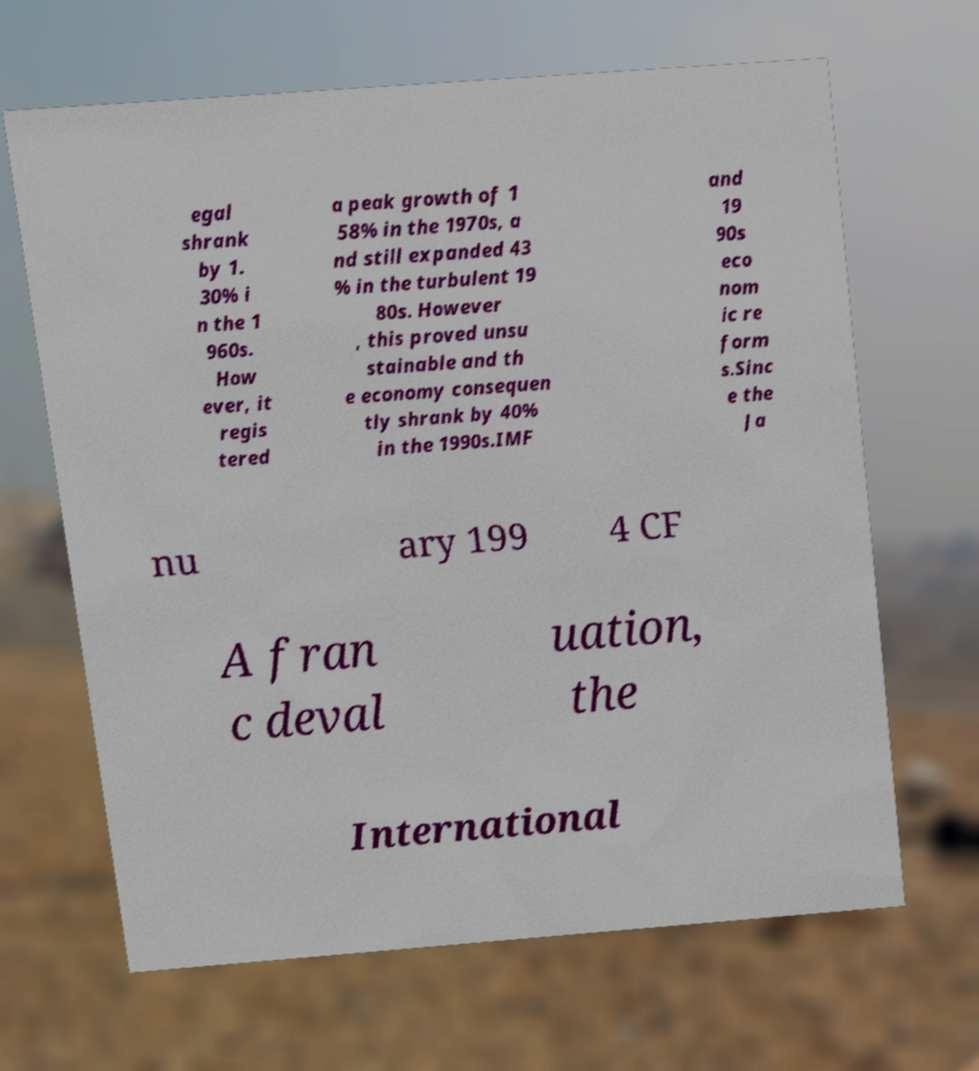For documentation purposes, I need the text within this image transcribed. Could you provide that? egal shrank by 1. 30% i n the 1 960s. How ever, it regis tered a peak growth of 1 58% in the 1970s, a nd still expanded 43 % in the turbulent 19 80s. However , this proved unsu stainable and th e economy consequen tly shrank by 40% in the 1990s.IMF and 19 90s eco nom ic re form s.Sinc e the Ja nu ary 199 4 CF A fran c deval uation, the International 